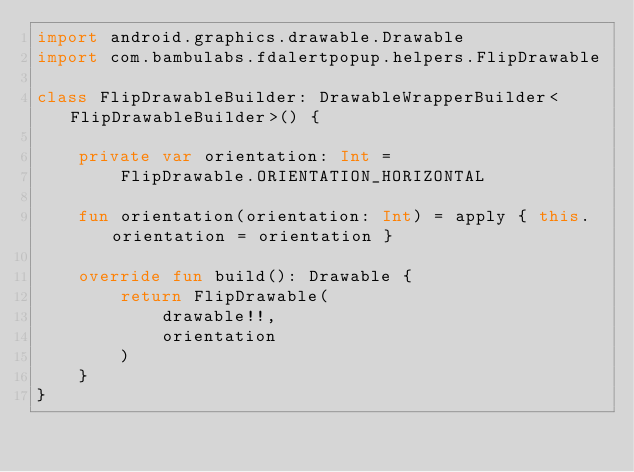<code> <loc_0><loc_0><loc_500><loc_500><_Kotlin_>import android.graphics.drawable.Drawable
import com.bambulabs.fdalertpopup.helpers.FlipDrawable

class FlipDrawableBuilder: DrawableWrapperBuilder<FlipDrawableBuilder>() {

    private var orientation: Int =
        FlipDrawable.ORIENTATION_HORIZONTAL

    fun orientation(orientation: Int) = apply { this.orientation = orientation }

    override fun build(): Drawable {
        return FlipDrawable(
            drawable!!,
            orientation
        )
    }
}</code> 